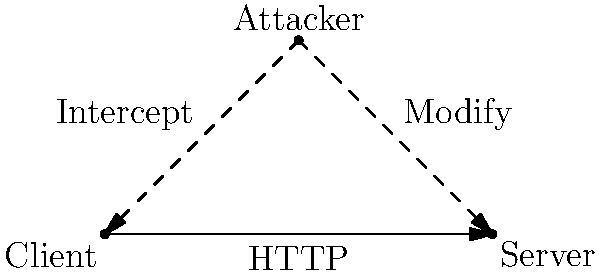Analyze the security vulnerabilities in the HTTP protocol as illustrated in the network diagram. Identify the primary weakness that allows the attacker to compromise the communication between the client and server, and propose a more secure alternative protocol. 1. Diagram analysis:
   - The diagram shows a client, server, and attacker in a triangle formation.
   - The client and server are communicating over HTTP.
   - The attacker can intercept and modify communications between client and server.

2. HTTP vulnerability:
   - HTTP transmits data in plaintext, making it susceptible to eavesdropping and manipulation.
   - The attacker can easily read and modify the unencrypted data passing between client and server.

3. Main weakness:
   - Lack of encryption in HTTP allows for man-in-the-middle (MITM) attacks.
   - The attacker can intercept, read, and modify data without detection.

4. Consequences:
   - Sensitive information (e.g., passwords, personal data) can be stolen.
   - The attacker can inject malicious content or modify legitimate requests/responses.

5. Secure alternative:
   - HTTPS (HTTP Secure) should be used instead of HTTP.
   - HTTPS uses SSL/TLS protocols to encrypt data in transit.

6. Benefits of HTTPS:
   - Provides confidentiality through encryption.
   - Ensures integrity by detecting any tampering with the data.
   - Offers authentication, verifying the identity of the server.

7. Implementation:
   - Websites should use SSL/TLS certificates and force HTTPS connections.
   - Browsers should warn users when accessing non-HTTPS sites.
Answer: HTTP's lack of encryption enables MITM attacks; use HTTPS for secure communication. 